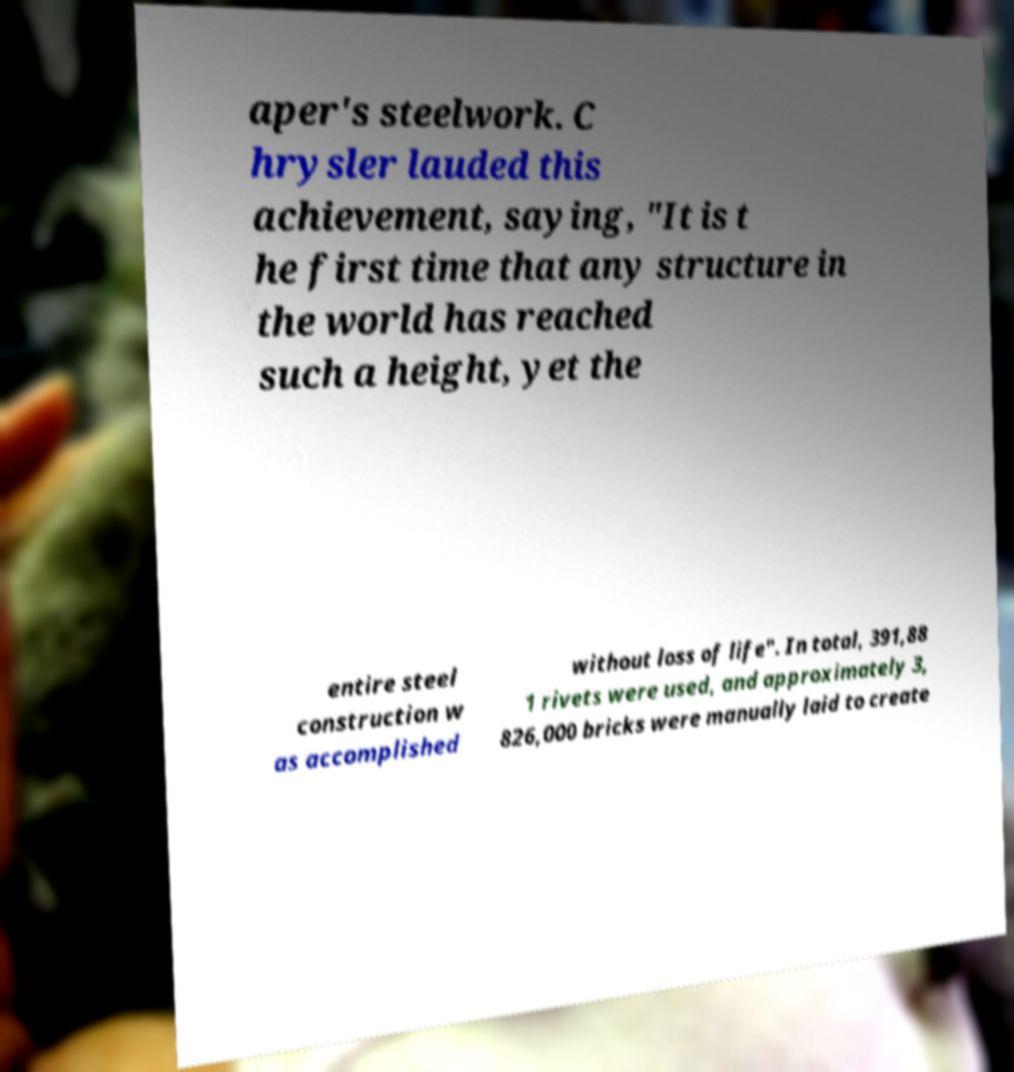Can you accurately transcribe the text from the provided image for me? aper's steelwork. C hrysler lauded this achievement, saying, "It is t he first time that any structure in the world has reached such a height, yet the entire steel construction w as accomplished without loss of life". In total, 391,88 1 rivets were used, and approximately 3, 826,000 bricks were manually laid to create 